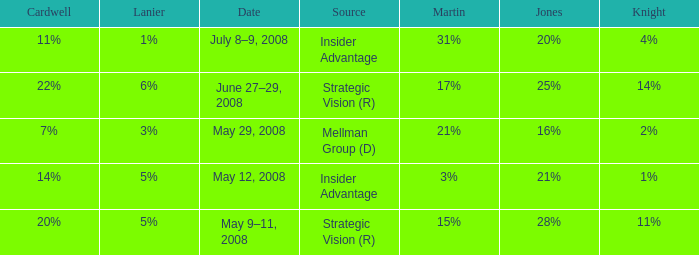What Lanier has a Cardwell of 20%? 5%. 